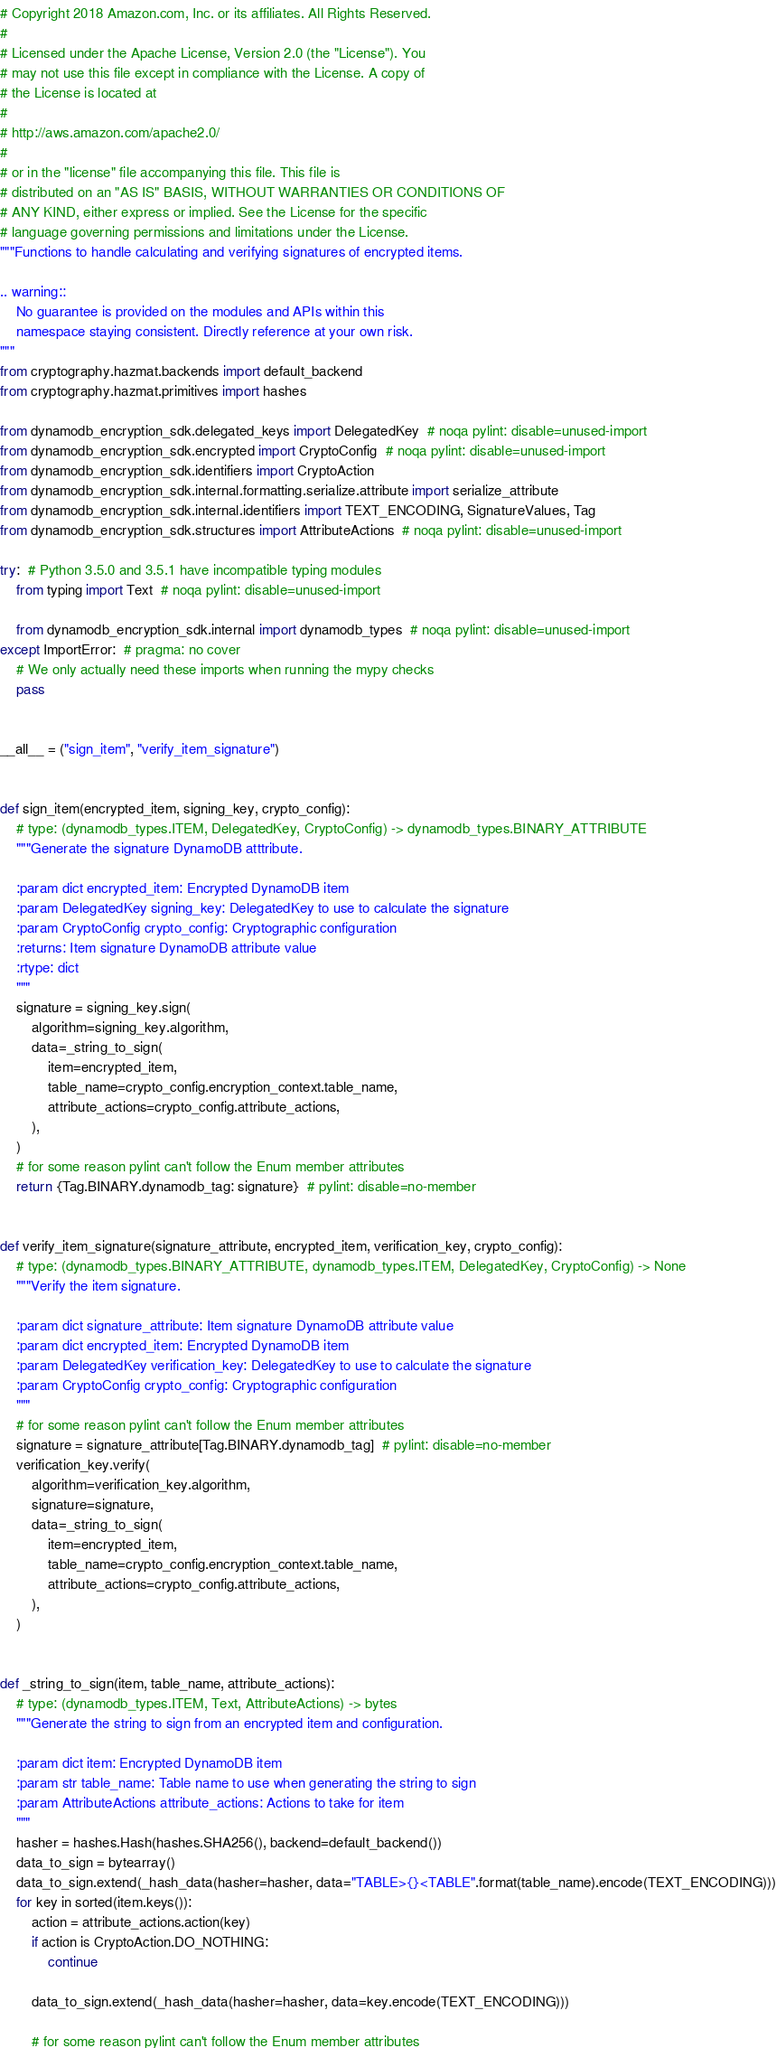<code> <loc_0><loc_0><loc_500><loc_500><_Python_># Copyright 2018 Amazon.com, Inc. or its affiliates. All Rights Reserved.
#
# Licensed under the Apache License, Version 2.0 (the "License"). You
# may not use this file except in compliance with the License. A copy of
# the License is located at
#
# http://aws.amazon.com/apache2.0/
#
# or in the "license" file accompanying this file. This file is
# distributed on an "AS IS" BASIS, WITHOUT WARRANTIES OR CONDITIONS OF
# ANY KIND, either express or implied. See the License for the specific
# language governing permissions and limitations under the License.
"""Functions to handle calculating and verifying signatures of encrypted items.

.. warning::
    No guarantee is provided on the modules and APIs within this
    namespace staying consistent. Directly reference at your own risk.
"""
from cryptography.hazmat.backends import default_backend
from cryptography.hazmat.primitives import hashes

from dynamodb_encryption_sdk.delegated_keys import DelegatedKey  # noqa pylint: disable=unused-import
from dynamodb_encryption_sdk.encrypted import CryptoConfig  # noqa pylint: disable=unused-import
from dynamodb_encryption_sdk.identifiers import CryptoAction
from dynamodb_encryption_sdk.internal.formatting.serialize.attribute import serialize_attribute
from dynamodb_encryption_sdk.internal.identifiers import TEXT_ENCODING, SignatureValues, Tag
from dynamodb_encryption_sdk.structures import AttributeActions  # noqa pylint: disable=unused-import

try:  # Python 3.5.0 and 3.5.1 have incompatible typing modules
    from typing import Text  # noqa pylint: disable=unused-import

    from dynamodb_encryption_sdk.internal import dynamodb_types  # noqa pylint: disable=unused-import
except ImportError:  # pragma: no cover
    # We only actually need these imports when running the mypy checks
    pass


__all__ = ("sign_item", "verify_item_signature")


def sign_item(encrypted_item, signing_key, crypto_config):
    # type: (dynamodb_types.ITEM, DelegatedKey, CryptoConfig) -> dynamodb_types.BINARY_ATTRIBUTE
    """Generate the signature DynamoDB atttribute.

    :param dict encrypted_item: Encrypted DynamoDB item
    :param DelegatedKey signing_key: DelegatedKey to use to calculate the signature
    :param CryptoConfig crypto_config: Cryptographic configuration
    :returns: Item signature DynamoDB attribute value
    :rtype: dict
    """
    signature = signing_key.sign(
        algorithm=signing_key.algorithm,
        data=_string_to_sign(
            item=encrypted_item,
            table_name=crypto_config.encryption_context.table_name,
            attribute_actions=crypto_config.attribute_actions,
        ),
    )
    # for some reason pylint can't follow the Enum member attributes
    return {Tag.BINARY.dynamodb_tag: signature}  # pylint: disable=no-member


def verify_item_signature(signature_attribute, encrypted_item, verification_key, crypto_config):
    # type: (dynamodb_types.BINARY_ATTRIBUTE, dynamodb_types.ITEM, DelegatedKey, CryptoConfig) -> None
    """Verify the item signature.

    :param dict signature_attribute: Item signature DynamoDB attribute value
    :param dict encrypted_item: Encrypted DynamoDB item
    :param DelegatedKey verification_key: DelegatedKey to use to calculate the signature
    :param CryptoConfig crypto_config: Cryptographic configuration
    """
    # for some reason pylint can't follow the Enum member attributes
    signature = signature_attribute[Tag.BINARY.dynamodb_tag]  # pylint: disable=no-member
    verification_key.verify(
        algorithm=verification_key.algorithm,
        signature=signature,
        data=_string_to_sign(
            item=encrypted_item,
            table_name=crypto_config.encryption_context.table_name,
            attribute_actions=crypto_config.attribute_actions,
        ),
    )


def _string_to_sign(item, table_name, attribute_actions):
    # type: (dynamodb_types.ITEM, Text, AttributeActions) -> bytes
    """Generate the string to sign from an encrypted item and configuration.

    :param dict item: Encrypted DynamoDB item
    :param str table_name: Table name to use when generating the string to sign
    :param AttributeActions attribute_actions: Actions to take for item
    """
    hasher = hashes.Hash(hashes.SHA256(), backend=default_backend())
    data_to_sign = bytearray()
    data_to_sign.extend(_hash_data(hasher=hasher, data="TABLE>{}<TABLE".format(table_name).encode(TEXT_ENCODING)))
    for key in sorted(item.keys()):
        action = attribute_actions.action(key)
        if action is CryptoAction.DO_NOTHING:
            continue

        data_to_sign.extend(_hash_data(hasher=hasher, data=key.encode(TEXT_ENCODING)))

        # for some reason pylint can't follow the Enum member attributes</code> 